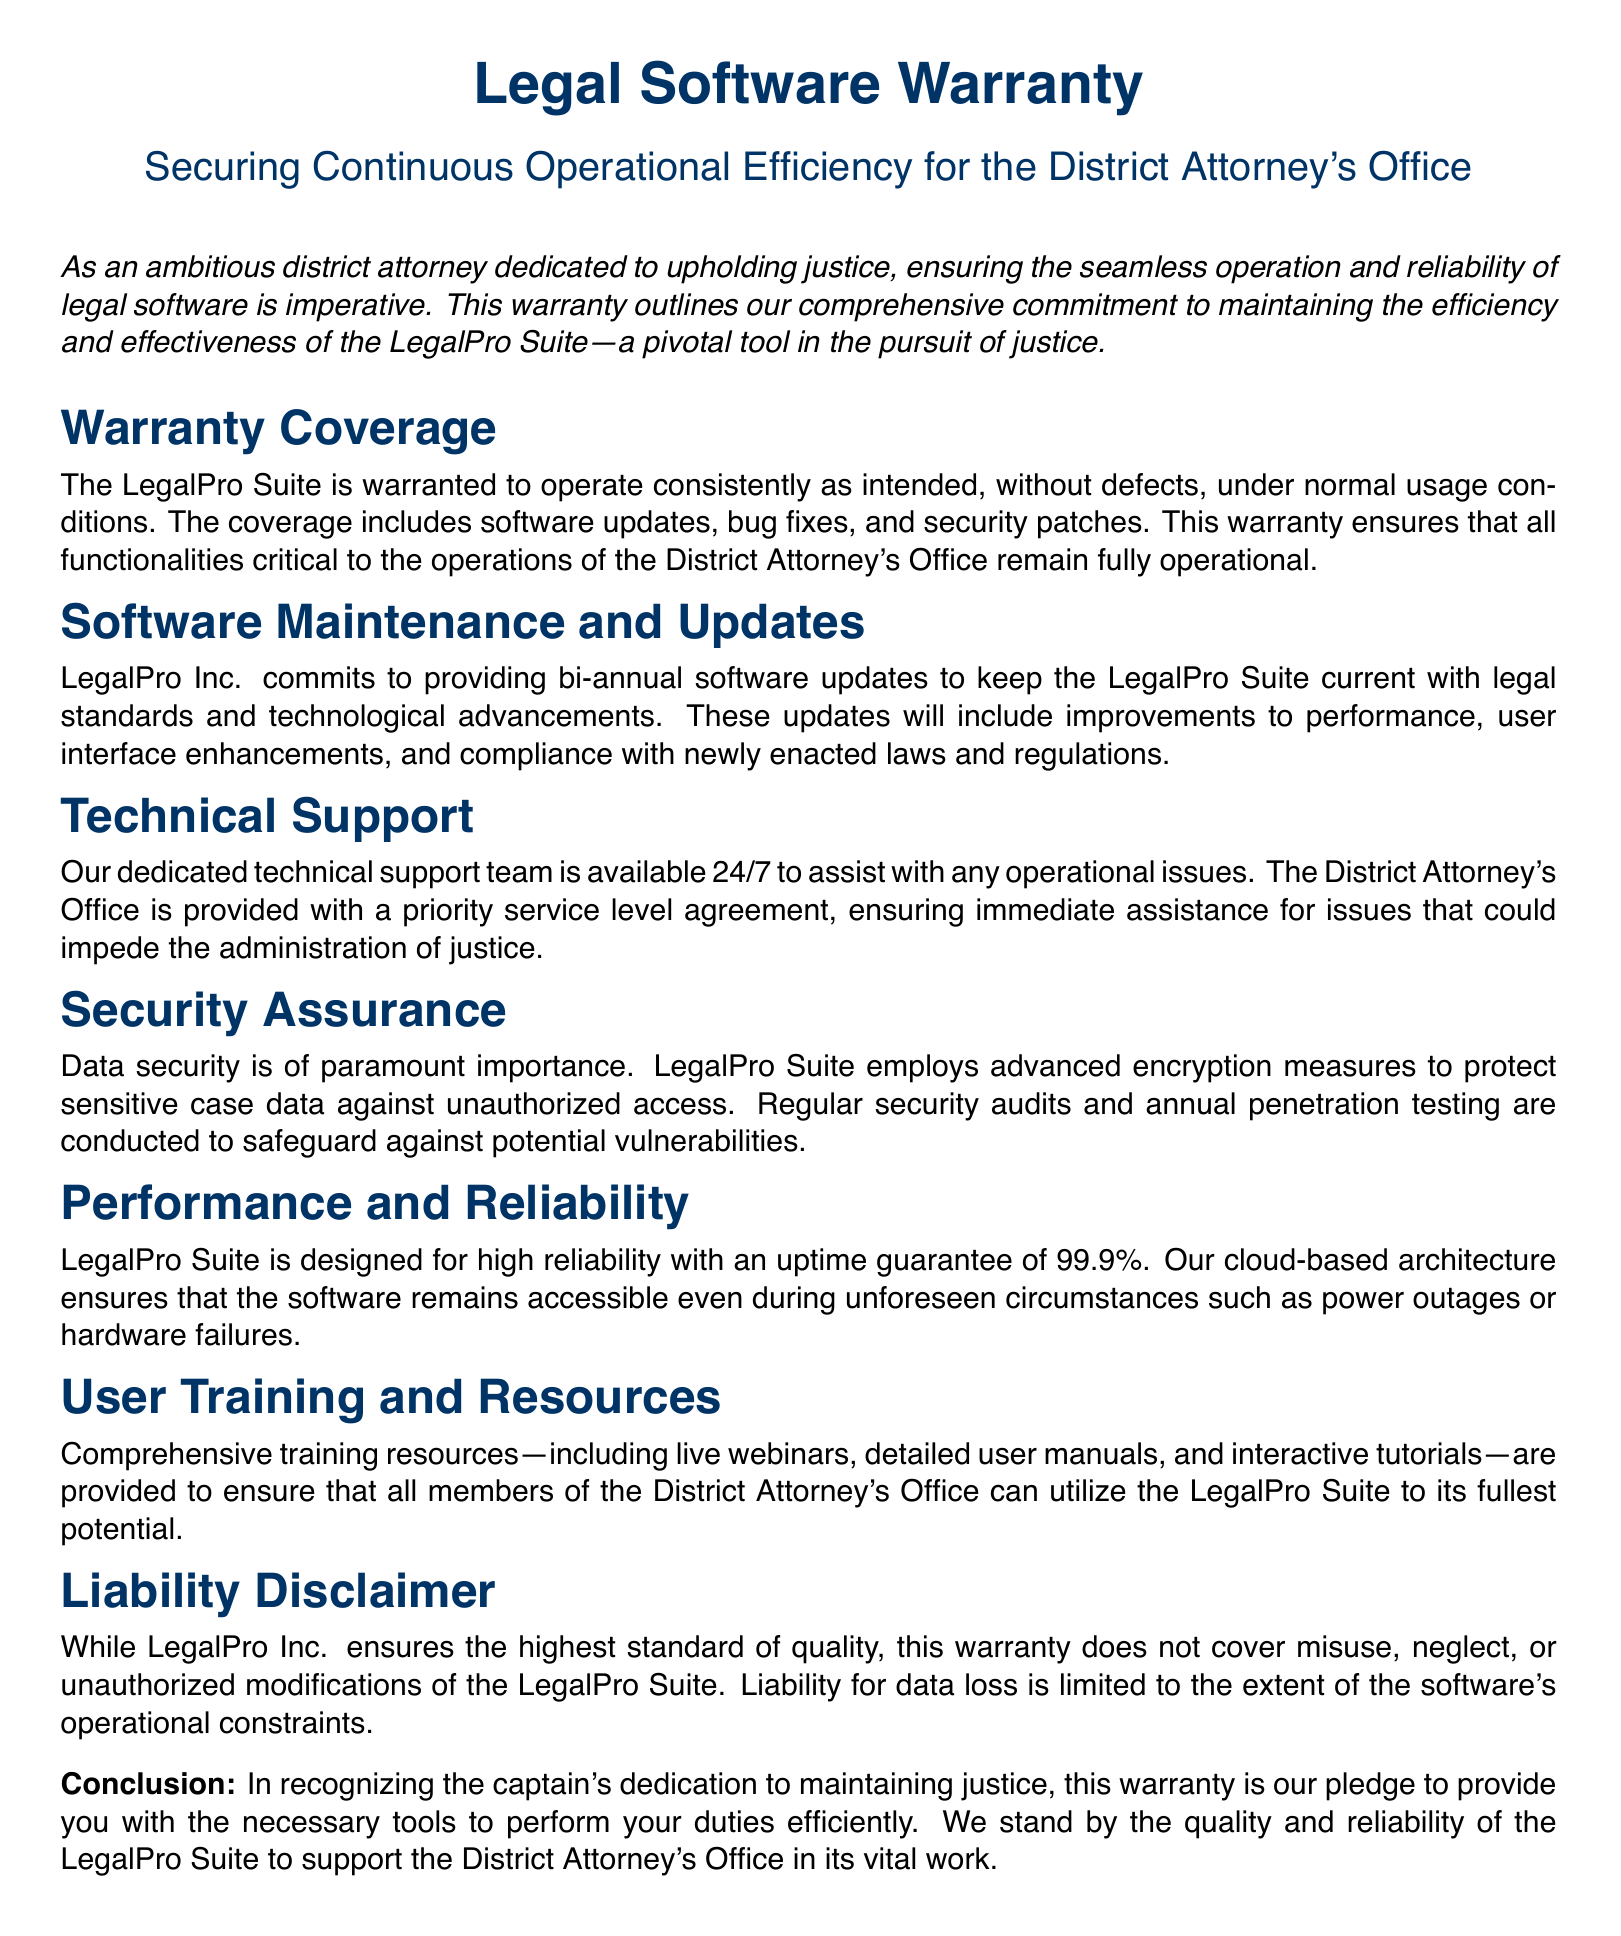What is the warranty coverage for the LegalPro Suite? The warranty coverage ensures the LegalPro Suite operates consistently as intended, without defects, under normal usage conditions.
Answer: Operates consistently as intended How often will software updates be provided? The document states that LegalPro Inc. commits to providing updates to keep the software current.
Answer: Bi-annual What is the uptime guarantee for the LegalPro Suite? The warranty specifies the uptime guarantee to indicate reliability.
Answer: 99.9% What type of support is offered by the technical support team? The document mentions the availability and priority service of the technical support team.
Answer: 24/7 priority service What security measures are employed to protect sensitive data? The warranty outlines the actions taken to ensure data security.
Answer: Advanced encryption measures Under what circumstances does the warranty not apply? This question addresses the liability disclaimer section of the document.
Answer: Misuse, neglect, or unauthorized modifications What type of training resources are available for users? The document lists the various training resources provided for effective use of the software.
Answer: Live webinars, detailed user manuals, and interactive tutorials How often are security audits conducted? The document mentions security audits as part of the security assurance.
Answer: Annually What is the purpose of the LegalPro Suite according to the document? This question asks about the overall goal of the software for the District Attorney's Office.
Answer: Support the District Attorney's Office in its vital work 